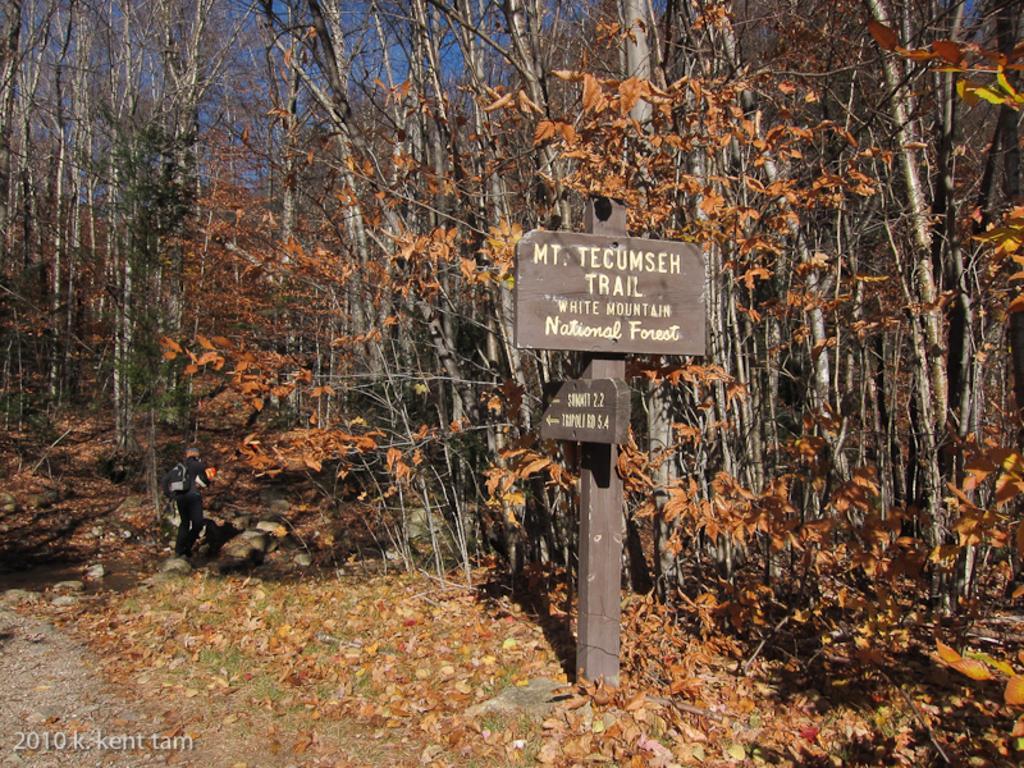Describe this image in one or two sentences. In front of the picture, we see a pole and the boards in brown color with some text written on it. At the bottom, we see the grass, dry leaves and the twigs. There are trees in the background. 